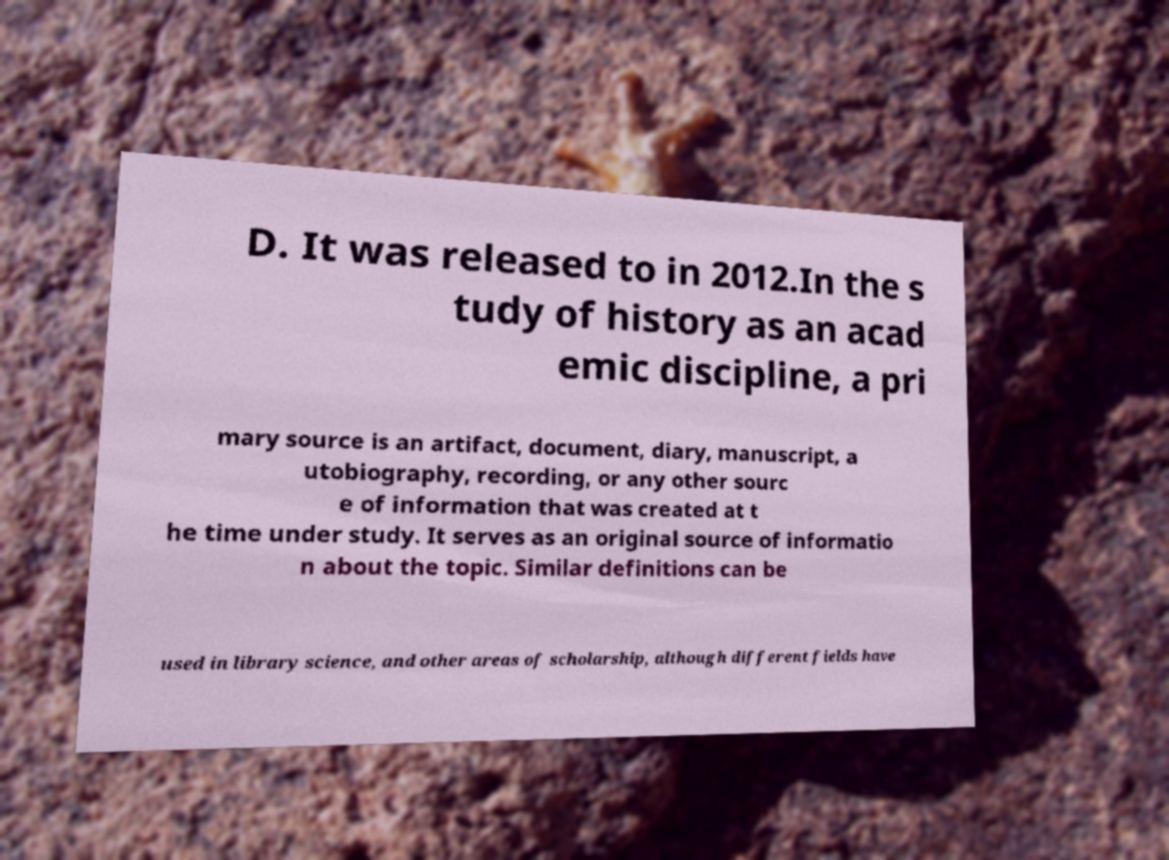Could you extract and type out the text from this image? D. It was released to in 2012.In the s tudy of history as an acad emic discipline, a pri mary source is an artifact, document, diary, manuscript, a utobiography, recording, or any other sourc e of information that was created at t he time under study. It serves as an original source of informatio n about the topic. Similar definitions can be used in library science, and other areas of scholarship, although different fields have 